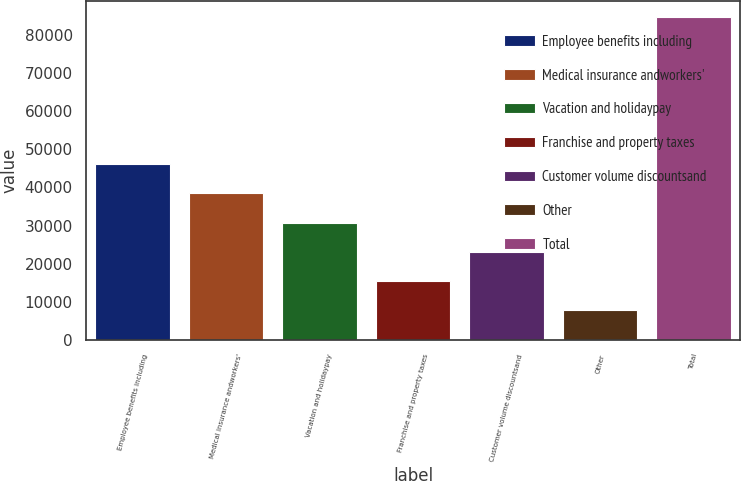<chart> <loc_0><loc_0><loc_500><loc_500><bar_chart><fcel>Employee benefits including<fcel>Medical insurance andworkers'<fcel>Vacation and holidaypay<fcel>Franchise and property taxes<fcel>Customer volume discountsand<fcel>Other<fcel>Total<nl><fcel>46160.5<fcel>38484<fcel>30807.5<fcel>15454.5<fcel>23131<fcel>7778<fcel>84543<nl></chart> 